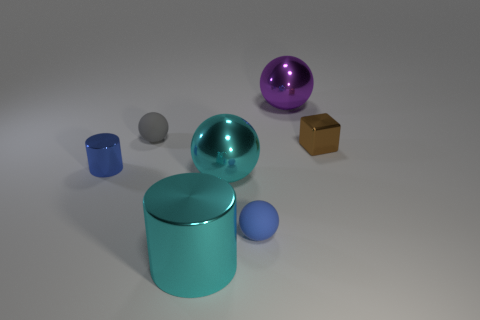Subtract 1 spheres. How many spheres are left? 3 Add 1 blue matte things. How many objects exist? 8 Subtract all cylinders. How many objects are left? 5 Subtract all yellow shiny blocks. Subtract all big metal things. How many objects are left? 4 Add 2 large purple metallic objects. How many large purple metallic objects are left? 3 Add 1 large purple metal spheres. How many large purple metal spheres exist? 2 Subtract 0 green cylinders. How many objects are left? 7 